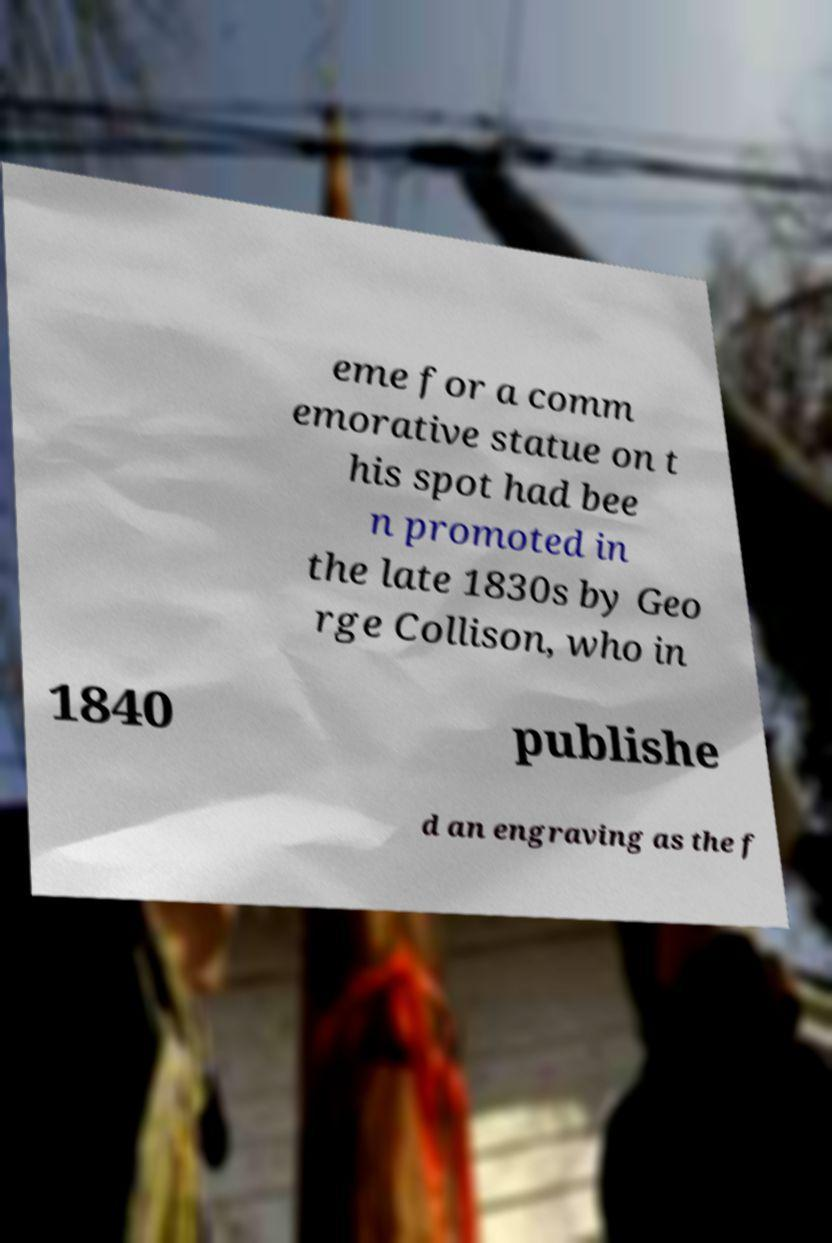Please identify and transcribe the text found in this image. eme for a comm emorative statue on t his spot had bee n promoted in the late 1830s by Geo rge Collison, who in 1840 publishe d an engraving as the f 